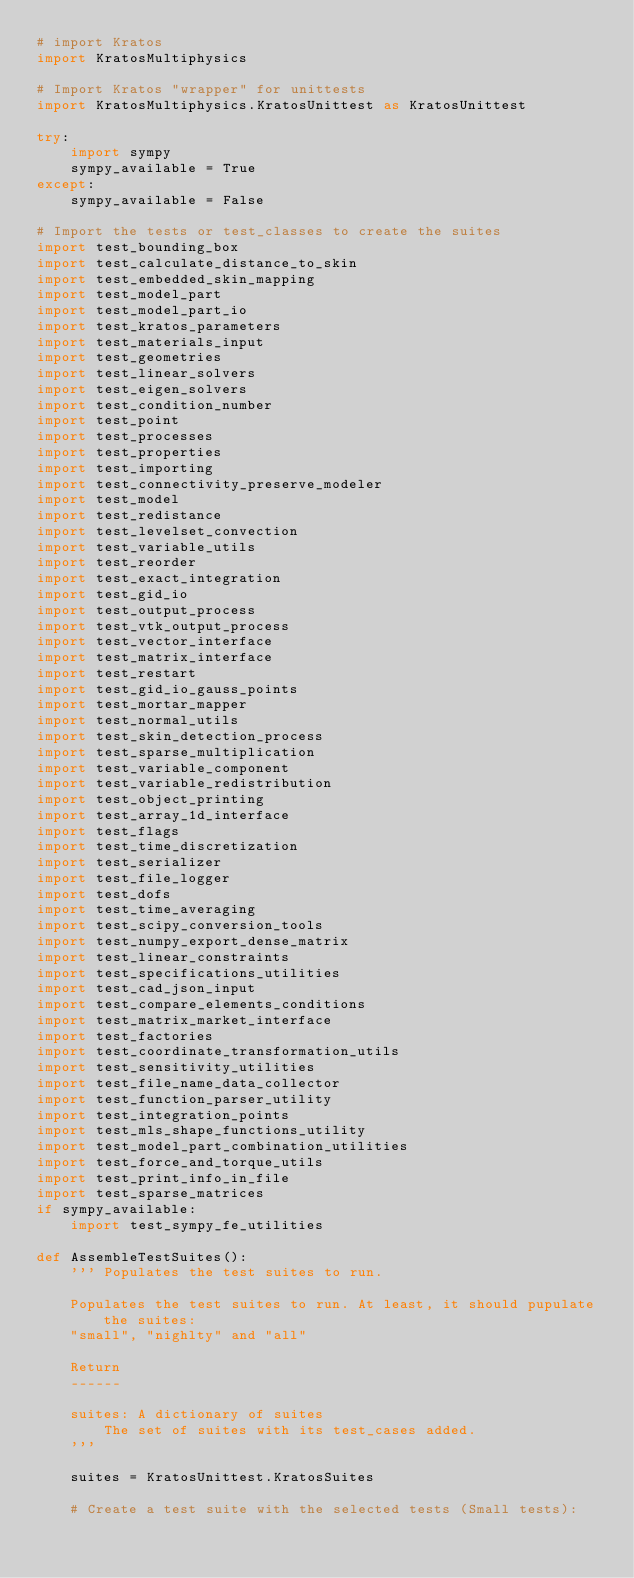<code> <loc_0><loc_0><loc_500><loc_500><_Python_># import Kratos
import KratosMultiphysics

# Import Kratos "wrapper" for unittests
import KratosMultiphysics.KratosUnittest as KratosUnittest

try:
    import sympy
    sympy_available = True
except:
    sympy_available = False

# Import the tests or test_classes to create the suites
import test_bounding_box
import test_calculate_distance_to_skin
import test_embedded_skin_mapping
import test_model_part
import test_model_part_io
import test_kratos_parameters
import test_materials_input
import test_geometries
import test_linear_solvers
import test_eigen_solvers
import test_condition_number
import test_point
import test_processes
import test_properties
import test_importing
import test_connectivity_preserve_modeler
import test_model
import test_redistance
import test_levelset_convection
import test_variable_utils
import test_reorder
import test_exact_integration
import test_gid_io
import test_output_process
import test_vtk_output_process
import test_vector_interface
import test_matrix_interface
import test_restart
import test_gid_io_gauss_points
import test_mortar_mapper
import test_normal_utils
import test_skin_detection_process
import test_sparse_multiplication
import test_variable_component
import test_variable_redistribution
import test_object_printing
import test_array_1d_interface
import test_flags
import test_time_discretization
import test_serializer
import test_file_logger
import test_dofs
import test_time_averaging
import test_scipy_conversion_tools
import test_numpy_export_dense_matrix
import test_linear_constraints
import test_specifications_utilities
import test_cad_json_input
import test_compare_elements_conditions
import test_matrix_market_interface
import test_factories
import test_coordinate_transformation_utils
import test_sensitivity_utilities
import test_file_name_data_collector
import test_function_parser_utility
import test_integration_points
import test_mls_shape_functions_utility
import test_model_part_combination_utilities
import test_force_and_torque_utils
import test_print_info_in_file
import test_sparse_matrices
if sympy_available:
    import test_sympy_fe_utilities

def AssembleTestSuites():
    ''' Populates the test suites to run.

    Populates the test suites to run. At least, it should pupulate the suites:
    "small", "nighlty" and "all"

    Return
    ------

    suites: A dictionary of suites
        The set of suites with its test_cases added.
    '''

    suites = KratosUnittest.KratosSuites

    # Create a test suite with the selected tests (Small tests):</code> 